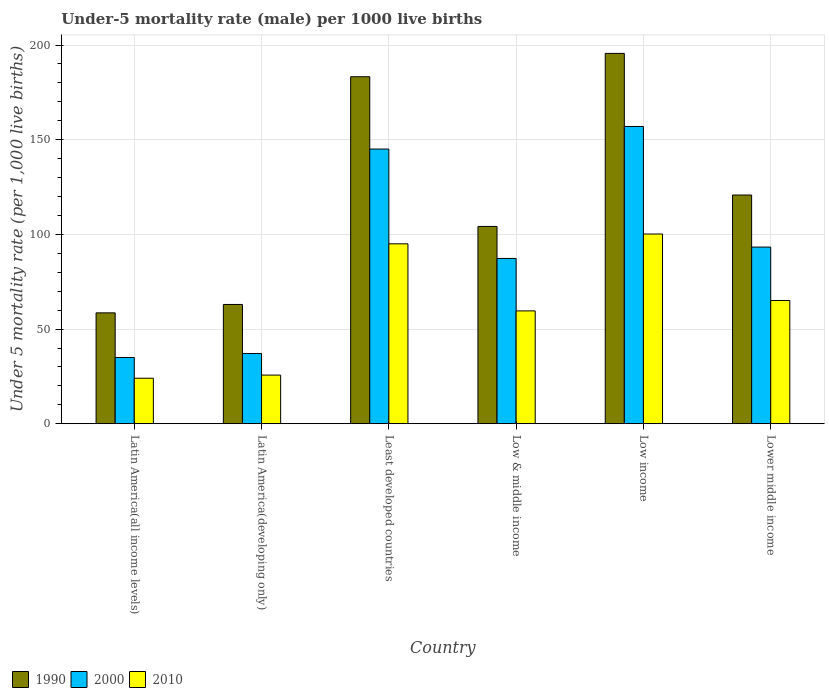How many different coloured bars are there?
Provide a succinct answer. 3. How many bars are there on the 4th tick from the right?
Offer a terse response. 3. What is the label of the 3rd group of bars from the left?
Give a very brief answer. Least developed countries. In how many cases, is the number of bars for a given country not equal to the number of legend labels?
Your answer should be compact. 0. What is the under-five mortality rate in 1990 in Low & middle income?
Make the answer very short. 104.2. Across all countries, what is the maximum under-five mortality rate in 2010?
Give a very brief answer. 100.2. Across all countries, what is the minimum under-five mortality rate in 1990?
Your answer should be very brief. 58.55. In which country was the under-five mortality rate in 1990 minimum?
Your answer should be very brief. Latin America(all income levels). What is the total under-five mortality rate in 2000 in the graph?
Offer a very short reply. 554.77. What is the difference between the under-five mortality rate in 1990 in Low & middle income and that in Low income?
Give a very brief answer. -91.4. What is the difference between the under-five mortality rate in 1990 in Low income and the under-five mortality rate in 2000 in Latin America(developing only)?
Provide a short and direct response. 158.5. What is the average under-five mortality rate in 1990 per country?
Your response must be concise. 120.91. What is the difference between the under-five mortality rate of/in 2010 and under-five mortality rate of/in 2000 in Low & middle income?
Make the answer very short. -27.7. In how many countries, is the under-five mortality rate in 2010 greater than 130?
Make the answer very short. 0. What is the ratio of the under-five mortality rate in 1990 in Low income to that in Lower middle income?
Make the answer very short. 1.62. Is the difference between the under-five mortality rate in 2010 in Low income and Lower middle income greater than the difference between the under-five mortality rate in 2000 in Low income and Lower middle income?
Provide a succinct answer. No. What is the difference between the highest and the second highest under-five mortality rate in 1990?
Your answer should be compact. -74.8. What is the difference between the highest and the lowest under-five mortality rate in 2010?
Keep it short and to the point. 76.16. In how many countries, is the under-five mortality rate in 1990 greater than the average under-five mortality rate in 1990 taken over all countries?
Make the answer very short. 2. Is the sum of the under-five mortality rate in 1990 in Latin America(all income levels) and Lower middle income greater than the maximum under-five mortality rate in 2010 across all countries?
Give a very brief answer. Yes. Are all the bars in the graph horizontal?
Your response must be concise. No. Where does the legend appear in the graph?
Provide a short and direct response. Bottom left. What is the title of the graph?
Provide a succinct answer. Under-5 mortality rate (male) per 1000 live births. What is the label or title of the X-axis?
Your response must be concise. Country. What is the label or title of the Y-axis?
Keep it short and to the point. Under 5 mortality rate (per 1,0 live births). What is the Under 5 mortality rate (per 1,000 live births) of 1990 in Latin America(all income levels)?
Provide a short and direct response. 58.55. What is the Under 5 mortality rate (per 1,000 live births) in 2000 in Latin America(all income levels)?
Your answer should be compact. 34.99. What is the Under 5 mortality rate (per 1,000 live births) of 2010 in Latin America(all income levels)?
Your answer should be very brief. 24.04. What is the Under 5 mortality rate (per 1,000 live births) in 1990 in Latin America(developing only)?
Your answer should be very brief. 63. What is the Under 5 mortality rate (per 1,000 live births) in 2000 in Latin America(developing only)?
Your answer should be compact. 37.1. What is the Under 5 mortality rate (per 1,000 live births) in 2010 in Latin America(developing only)?
Provide a short and direct response. 25.7. What is the Under 5 mortality rate (per 1,000 live births) in 1990 in Least developed countries?
Your response must be concise. 183.28. What is the Under 5 mortality rate (per 1,000 live births) of 2000 in Least developed countries?
Offer a very short reply. 145.08. What is the Under 5 mortality rate (per 1,000 live births) in 2010 in Least developed countries?
Your answer should be compact. 95.03. What is the Under 5 mortality rate (per 1,000 live births) in 1990 in Low & middle income?
Your answer should be very brief. 104.2. What is the Under 5 mortality rate (per 1,000 live births) in 2000 in Low & middle income?
Your answer should be compact. 87.3. What is the Under 5 mortality rate (per 1,000 live births) of 2010 in Low & middle income?
Offer a very short reply. 59.6. What is the Under 5 mortality rate (per 1,000 live births) in 1990 in Low income?
Make the answer very short. 195.6. What is the Under 5 mortality rate (per 1,000 live births) in 2000 in Low income?
Make the answer very short. 157. What is the Under 5 mortality rate (per 1,000 live births) in 2010 in Low income?
Your answer should be compact. 100.2. What is the Under 5 mortality rate (per 1,000 live births) of 1990 in Lower middle income?
Ensure brevity in your answer.  120.8. What is the Under 5 mortality rate (per 1,000 live births) in 2000 in Lower middle income?
Provide a succinct answer. 93.3. What is the Under 5 mortality rate (per 1,000 live births) of 2010 in Lower middle income?
Offer a very short reply. 65.1. Across all countries, what is the maximum Under 5 mortality rate (per 1,000 live births) of 1990?
Offer a terse response. 195.6. Across all countries, what is the maximum Under 5 mortality rate (per 1,000 live births) in 2000?
Provide a short and direct response. 157. Across all countries, what is the maximum Under 5 mortality rate (per 1,000 live births) in 2010?
Your response must be concise. 100.2. Across all countries, what is the minimum Under 5 mortality rate (per 1,000 live births) in 1990?
Your answer should be compact. 58.55. Across all countries, what is the minimum Under 5 mortality rate (per 1,000 live births) in 2000?
Your answer should be very brief. 34.99. Across all countries, what is the minimum Under 5 mortality rate (per 1,000 live births) in 2010?
Your answer should be very brief. 24.04. What is the total Under 5 mortality rate (per 1,000 live births) in 1990 in the graph?
Your answer should be very brief. 725.43. What is the total Under 5 mortality rate (per 1,000 live births) in 2000 in the graph?
Offer a very short reply. 554.77. What is the total Under 5 mortality rate (per 1,000 live births) in 2010 in the graph?
Offer a very short reply. 369.66. What is the difference between the Under 5 mortality rate (per 1,000 live births) of 1990 in Latin America(all income levels) and that in Latin America(developing only)?
Offer a very short reply. -4.45. What is the difference between the Under 5 mortality rate (per 1,000 live births) of 2000 in Latin America(all income levels) and that in Latin America(developing only)?
Your response must be concise. -2.11. What is the difference between the Under 5 mortality rate (per 1,000 live births) in 2010 in Latin America(all income levels) and that in Latin America(developing only)?
Offer a very short reply. -1.66. What is the difference between the Under 5 mortality rate (per 1,000 live births) of 1990 in Latin America(all income levels) and that in Least developed countries?
Ensure brevity in your answer.  -124.72. What is the difference between the Under 5 mortality rate (per 1,000 live births) in 2000 in Latin America(all income levels) and that in Least developed countries?
Keep it short and to the point. -110.09. What is the difference between the Under 5 mortality rate (per 1,000 live births) of 2010 in Latin America(all income levels) and that in Least developed countries?
Keep it short and to the point. -70.99. What is the difference between the Under 5 mortality rate (per 1,000 live births) in 1990 in Latin America(all income levels) and that in Low & middle income?
Provide a succinct answer. -45.65. What is the difference between the Under 5 mortality rate (per 1,000 live births) in 2000 in Latin America(all income levels) and that in Low & middle income?
Make the answer very short. -52.31. What is the difference between the Under 5 mortality rate (per 1,000 live births) of 2010 in Latin America(all income levels) and that in Low & middle income?
Ensure brevity in your answer.  -35.56. What is the difference between the Under 5 mortality rate (per 1,000 live births) in 1990 in Latin America(all income levels) and that in Low income?
Provide a short and direct response. -137.05. What is the difference between the Under 5 mortality rate (per 1,000 live births) of 2000 in Latin America(all income levels) and that in Low income?
Give a very brief answer. -122.01. What is the difference between the Under 5 mortality rate (per 1,000 live births) of 2010 in Latin America(all income levels) and that in Low income?
Ensure brevity in your answer.  -76.16. What is the difference between the Under 5 mortality rate (per 1,000 live births) in 1990 in Latin America(all income levels) and that in Lower middle income?
Give a very brief answer. -62.25. What is the difference between the Under 5 mortality rate (per 1,000 live births) of 2000 in Latin America(all income levels) and that in Lower middle income?
Your answer should be compact. -58.31. What is the difference between the Under 5 mortality rate (per 1,000 live births) in 2010 in Latin America(all income levels) and that in Lower middle income?
Make the answer very short. -41.06. What is the difference between the Under 5 mortality rate (per 1,000 live births) of 1990 in Latin America(developing only) and that in Least developed countries?
Give a very brief answer. -120.28. What is the difference between the Under 5 mortality rate (per 1,000 live births) in 2000 in Latin America(developing only) and that in Least developed countries?
Provide a succinct answer. -107.98. What is the difference between the Under 5 mortality rate (per 1,000 live births) of 2010 in Latin America(developing only) and that in Least developed countries?
Offer a very short reply. -69.33. What is the difference between the Under 5 mortality rate (per 1,000 live births) of 1990 in Latin America(developing only) and that in Low & middle income?
Your answer should be compact. -41.2. What is the difference between the Under 5 mortality rate (per 1,000 live births) in 2000 in Latin America(developing only) and that in Low & middle income?
Offer a terse response. -50.2. What is the difference between the Under 5 mortality rate (per 1,000 live births) in 2010 in Latin America(developing only) and that in Low & middle income?
Offer a terse response. -33.9. What is the difference between the Under 5 mortality rate (per 1,000 live births) of 1990 in Latin America(developing only) and that in Low income?
Provide a short and direct response. -132.6. What is the difference between the Under 5 mortality rate (per 1,000 live births) of 2000 in Latin America(developing only) and that in Low income?
Make the answer very short. -119.9. What is the difference between the Under 5 mortality rate (per 1,000 live births) in 2010 in Latin America(developing only) and that in Low income?
Provide a succinct answer. -74.5. What is the difference between the Under 5 mortality rate (per 1,000 live births) in 1990 in Latin America(developing only) and that in Lower middle income?
Give a very brief answer. -57.8. What is the difference between the Under 5 mortality rate (per 1,000 live births) of 2000 in Latin America(developing only) and that in Lower middle income?
Give a very brief answer. -56.2. What is the difference between the Under 5 mortality rate (per 1,000 live births) in 2010 in Latin America(developing only) and that in Lower middle income?
Your answer should be compact. -39.4. What is the difference between the Under 5 mortality rate (per 1,000 live births) in 1990 in Least developed countries and that in Low & middle income?
Provide a short and direct response. 79.08. What is the difference between the Under 5 mortality rate (per 1,000 live births) of 2000 in Least developed countries and that in Low & middle income?
Your answer should be very brief. 57.78. What is the difference between the Under 5 mortality rate (per 1,000 live births) of 2010 in Least developed countries and that in Low & middle income?
Keep it short and to the point. 35.43. What is the difference between the Under 5 mortality rate (per 1,000 live births) in 1990 in Least developed countries and that in Low income?
Provide a succinct answer. -12.32. What is the difference between the Under 5 mortality rate (per 1,000 live births) of 2000 in Least developed countries and that in Low income?
Ensure brevity in your answer.  -11.92. What is the difference between the Under 5 mortality rate (per 1,000 live births) in 2010 in Least developed countries and that in Low income?
Keep it short and to the point. -5.17. What is the difference between the Under 5 mortality rate (per 1,000 live births) in 1990 in Least developed countries and that in Lower middle income?
Keep it short and to the point. 62.48. What is the difference between the Under 5 mortality rate (per 1,000 live births) of 2000 in Least developed countries and that in Lower middle income?
Provide a short and direct response. 51.78. What is the difference between the Under 5 mortality rate (per 1,000 live births) of 2010 in Least developed countries and that in Lower middle income?
Your answer should be compact. 29.93. What is the difference between the Under 5 mortality rate (per 1,000 live births) in 1990 in Low & middle income and that in Low income?
Your answer should be compact. -91.4. What is the difference between the Under 5 mortality rate (per 1,000 live births) of 2000 in Low & middle income and that in Low income?
Give a very brief answer. -69.7. What is the difference between the Under 5 mortality rate (per 1,000 live births) in 2010 in Low & middle income and that in Low income?
Provide a succinct answer. -40.6. What is the difference between the Under 5 mortality rate (per 1,000 live births) in 1990 in Low & middle income and that in Lower middle income?
Ensure brevity in your answer.  -16.6. What is the difference between the Under 5 mortality rate (per 1,000 live births) of 2000 in Low & middle income and that in Lower middle income?
Your answer should be compact. -6. What is the difference between the Under 5 mortality rate (per 1,000 live births) of 1990 in Low income and that in Lower middle income?
Your answer should be very brief. 74.8. What is the difference between the Under 5 mortality rate (per 1,000 live births) of 2000 in Low income and that in Lower middle income?
Provide a short and direct response. 63.7. What is the difference between the Under 5 mortality rate (per 1,000 live births) of 2010 in Low income and that in Lower middle income?
Keep it short and to the point. 35.1. What is the difference between the Under 5 mortality rate (per 1,000 live births) of 1990 in Latin America(all income levels) and the Under 5 mortality rate (per 1,000 live births) of 2000 in Latin America(developing only)?
Your answer should be very brief. 21.45. What is the difference between the Under 5 mortality rate (per 1,000 live births) in 1990 in Latin America(all income levels) and the Under 5 mortality rate (per 1,000 live births) in 2010 in Latin America(developing only)?
Your answer should be very brief. 32.85. What is the difference between the Under 5 mortality rate (per 1,000 live births) of 2000 in Latin America(all income levels) and the Under 5 mortality rate (per 1,000 live births) of 2010 in Latin America(developing only)?
Give a very brief answer. 9.29. What is the difference between the Under 5 mortality rate (per 1,000 live births) of 1990 in Latin America(all income levels) and the Under 5 mortality rate (per 1,000 live births) of 2000 in Least developed countries?
Offer a very short reply. -86.52. What is the difference between the Under 5 mortality rate (per 1,000 live births) of 1990 in Latin America(all income levels) and the Under 5 mortality rate (per 1,000 live births) of 2010 in Least developed countries?
Offer a very short reply. -36.47. What is the difference between the Under 5 mortality rate (per 1,000 live births) in 2000 in Latin America(all income levels) and the Under 5 mortality rate (per 1,000 live births) in 2010 in Least developed countries?
Your response must be concise. -60.04. What is the difference between the Under 5 mortality rate (per 1,000 live births) in 1990 in Latin America(all income levels) and the Under 5 mortality rate (per 1,000 live births) in 2000 in Low & middle income?
Ensure brevity in your answer.  -28.75. What is the difference between the Under 5 mortality rate (per 1,000 live births) in 1990 in Latin America(all income levels) and the Under 5 mortality rate (per 1,000 live births) in 2010 in Low & middle income?
Your response must be concise. -1.05. What is the difference between the Under 5 mortality rate (per 1,000 live births) in 2000 in Latin America(all income levels) and the Under 5 mortality rate (per 1,000 live births) in 2010 in Low & middle income?
Your answer should be compact. -24.61. What is the difference between the Under 5 mortality rate (per 1,000 live births) of 1990 in Latin America(all income levels) and the Under 5 mortality rate (per 1,000 live births) of 2000 in Low income?
Make the answer very short. -98.45. What is the difference between the Under 5 mortality rate (per 1,000 live births) of 1990 in Latin America(all income levels) and the Under 5 mortality rate (per 1,000 live births) of 2010 in Low income?
Keep it short and to the point. -41.65. What is the difference between the Under 5 mortality rate (per 1,000 live births) of 2000 in Latin America(all income levels) and the Under 5 mortality rate (per 1,000 live births) of 2010 in Low income?
Make the answer very short. -65.21. What is the difference between the Under 5 mortality rate (per 1,000 live births) of 1990 in Latin America(all income levels) and the Under 5 mortality rate (per 1,000 live births) of 2000 in Lower middle income?
Ensure brevity in your answer.  -34.75. What is the difference between the Under 5 mortality rate (per 1,000 live births) in 1990 in Latin America(all income levels) and the Under 5 mortality rate (per 1,000 live births) in 2010 in Lower middle income?
Your answer should be very brief. -6.55. What is the difference between the Under 5 mortality rate (per 1,000 live births) in 2000 in Latin America(all income levels) and the Under 5 mortality rate (per 1,000 live births) in 2010 in Lower middle income?
Ensure brevity in your answer.  -30.11. What is the difference between the Under 5 mortality rate (per 1,000 live births) of 1990 in Latin America(developing only) and the Under 5 mortality rate (per 1,000 live births) of 2000 in Least developed countries?
Provide a short and direct response. -82.08. What is the difference between the Under 5 mortality rate (per 1,000 live births) of 1990 in Latin America(developing only) and the Under 5 mortality rate (per 1,000 live births) of 2010 in Least developed countries?
Provide a succinct answer. -32.03. What is the difference between the Under 5 mortality rate (per 1,000 live births) of 2000 in Latin America(developing only) and the Under 5 mortality rate (per 1,000 live births) of 2010 in Least developed countries?
Your answer should be very brief. -57.93. What is the difference between the Under 5 mortality rate (per 1,000 live births) in 1990 in Latin America(developing only) and the Under 5 mortality rate (per 1,000 live births) in 2000 in Low & middle income?
Offer a very short reply. -24.3. What is the difference between the Under 5 mortality rate (per 1,000 live births) in 2000 in Latin America(developing only) and the Under 5 mortality rate (per 1,000 live births) in 2010 in Low & middle income?
Give a very brief answer. -22.5. What is the difference between the Under 5 mortality rate (per 1,000 live births) of 1990 in Latin America(developing only) and the Under 5 mortality rate (per 1,000 live births) of 2000 in Low income?
Provide a succinct answer. -94. What is the difference between the Under 5 mortality rate (per 1,000 live births) in 1990 in Latin America(developing only) and the Under 5 mortality rate (per 1,000 live births) in 2010 in Low income?
Offer a terse response. -37.2. What is the difference between the Under 5 mortality rate (per 1,000 live births) of 2000 in Latin America(developing only) and the Under 5 mortality rate (per 1,000 live births) of 2010 in Low income?
Provide a short and direct response. -63.1. What is the difference between the Under 5 mortality rate (per 1,000 live births) in 1990 in Latin America(developing only) and the Under 5 mortality rate (per 1,000 live births) in 2000 in Lower middle income?
Provide a succinct answer. -30.3. What is the difference between the Under 5 mortality rate (per 1,000 live births) in 1990 in Latin America(developing only) and the Under 5 mortality rate (per 1,000 live births) in 2010 in Lower middle income?
Offer a terse response. -2.1. What is the difference between the Under 5 mortality rate (per 1,000 live births) of 1990 in Least developed countries and the Under 5 mortality rate (per 1,000 live births) of 2000 in Low & middle income?
Give a very brief answer. 95.98. What is the difference between the Under 5 mortality rate (per 1,000 live births) in 1990 in Least developed countries and the Under 5 mortality rate (per 1,000 live births) in 2010 in Low & middle income?
Provide a short and direct response. 123.68. What is the difference between the Under 5 mortality rate (per 1,000 live births) of 2000 in Least developed countries and the Under 5 mortality rate (per 1,000 live births) of 2010 in Low & middle income?
Offer a terse response. 85.48. What is the difference between the Under 5 mortality rate (per 1,000 live births) in 1990 in Least developed countries and the Under 5 mortality rate (per 1,000 live births) in 2000 in Low income?
Keep it short and to the point. 26.28. What is the difference between the Under 5 mortality rate (per 1,000 live births) of 1990 in Least developed countries and the Under 5 mortality rate (per 1,000 live births) of 2010 in Low income?
Make the answer very short. 83.08. What is the difference between the Under 5 mortality rate (per 1,000 live births) of 2000 in Least developed countries and the Under 5 mortality rate (per 1,000 live births) of 2010 in Low income?
Your response must be concise. 44.88. What is the difference between the Under 5 mortality rate (per 1,000 live births) of 1990 in Least developed countries and the Under 5 mortality rate (per 1,000 live births) of 2000 in Lower middle income?
Provide a succinct answer. 89.98. What is the difference between the Under 5 mortality rate (per 1,000 live births) of 1990 in Least developed countries and the Under 5 mortality rate (per 1,000 live births) of 2010 in Lower middle income?
Offer a very short reply. 118.18. What is the difference between the Under 5 mortality rate (per 1,000 live births) in 2000 in Least developed countries and the Under 5 mortality rate (per 1,000 live births) in 2010 in Lower middle income?
Ensure brevity in your answer.  79.98. What is the difference between the Under 5 mortality rate (per 1,000 live births) of 1990 in Low & middle income and the Under 5 mortality rate (per 1,000 live births) of 2000 in Low income?
Give a very brief answer. -52.8. What is the difference between the Under 5 mortality rate (per 1,000 live births) in 1990 in Low & middle income and the Under 5 mortality rate (per 1,000 live births) in 2010 in Lower middle income?
Offer a terse response. 39.1. What is the difference between the Under 5 mortality rate (per 1,000 live births) of 1990 in Low income and the Under 5 mortality rate (per 1,000 live births) of 2000 in Lower middle income?
Provide a succinct answer. 102.3. What is the difference between the Under 5 mortality rate (per 1,000 live births) in 1990 in Low income and the Under 5 mortality rate (per 1,000 live births) in 2010 in Lower middle income?
Offer a very short reply. 130.5. What is the difference between the Under 5 mortality rate (per 1,000 live births) in 2000 in Low income and the Under 5 mortality rate (per 1,000 live births) in 2010 in Lower middle income?
Provide a short and direct response. 91.9. What is the average Under 5 mortality rate (per 1,000 live births) in 1990 per country?
Give a very brief answer. 120.91. What is the average Under 5 mortality rate (per 1,000 live births) of 2000 per country?
Your response must be concise. 92.46. What is the average Under 5 mortality rate (per 1,000 live births) in 2010 per country?
Provide a short and direct response. 61.61. What is the difference between the Under 5 mortality rate (per 1,000 live births) of 1990 and Under 5 mortality rate (per 1,000 live births) of 2000 in Latin America(all income levels)?
Make the answer very short. 23.57. What is the difference between the Under 5 mortality rate (per 1,000 live births) of 1990 and Under 5 mortality rate (per 1,000 live births) of 2010 in Latin America(all income levels)?
Your response must be concise. 34.52. What is the difference between the Under 5 mortality rate (per 1,000 live births) in 2000 and Under 5 mortality rate (per 1,000 live births) in 2010 in Latin America(all income levels)?
Your response must be concise. 10.95. What is the difference between the Under 5 mortality rate (per 1,000 live births) of 1990 and Under 5 mortality rate (per 1,000 live births) of 2000 in Latin America(developing only)?
Offer a very short reply. 25.9. What is the difference between the Under 5 mortality rate (per 1,000 live births) in 1990 and Under 5 mortality rate (per 1,000 live births) in 2010 in Latin America(developing only)?
Your answer should be compact. 37.3. What is the difference between the Under 5 mortality rate (per 1,000 live births) in 1990 and Under 5 mortality rate (per 1,000 live births) in 2000 in Least developed countries?
Give a very brief answer. 38.2. What is the difference between the Under 5 mortality rate (per 1,000 live births) in 1990 and Under 5 mortality rate (per 1,000 live births) in 2010 in Least developed countries?
Provide a short and direct response. 88.25. What is the difference between the Under 5 mortality rate (per 1,000 live births) of 2000 and Under 5 mortality rate (per 1,000 live births) of 2010 in Least developed countries?
Your answer should be very brief. 50.05. What is the difference between the Under 5 mortality rate (per 1,000 live births) of 1990 and Under 5 mortality rate (per 1,000 live births) of 2000 in Low & middle income?
Provide a short and direct response. 16.9. What is the difference between the Under 5 mortality rate (per 1,000 live births) in 1990 and Under 5 mortality rate (per 1,000 live births) in 2010 in Low & middle income?
Provide a succinct answer. 44.6. What is the difference between the Under 5 mortality rate (per 1,000 live births) in 2000 and Under 5 mortality rate (per 1,000 live births) in 2010 in Low & middle income?
Ensure brevity in your answer.  27.7. What is the difference between the Under 5 mortality rate (per 1,000 live births) of 1990 and Under 5 mortality rate (per 1,000 live births) of 2000 in Low income?
Make the answer very short. 38.6. What is the difference between the Under 5 mortality rate (per 1,000 live births) in 1990 and Under 5 mortality rate (per 1,000 live births) in 2010 in Low income?
Make the answer very short. 95.4. What is the difference between the Under 5 mortality rate (per 1,000 live births) in 2000 and Under 5 mortality rate (per 1,000 live births) in 2010 in Low income?
Your response must be concise. 56.8. What is the difference between the Under 5 mortality rate (per 1,000 live births) in 1990 and Under 5 mortality rate (per 1,000 live births) in 2000 in Lower middle income?
Your response must be concise. 27.5. What is the difference between the Under 5 mortality rate (per 1,000 live births) of 1990 and Under 5 mortality rate (per 1,000 live births) of 2010 in Lower middle income?
Your answer should be very brief. 55.7. What is the difference between the Under 5 mortality rate (per 1,000 live births) of 2000 and Under 5 mortality rate (per 1,000 live births) of 2010 in Lower middle income?
Ensure brevity in your answer.  28.2. What is the ratio of the Under 5 mortality rate (per 1,000 live births) in 1990 in Latin America(all income levels) to that in Latin America(developing only)?
Provide a short and direct response. 0.93. What is the ratio of the Under 5 mortality rate (per 1,000 live births) of 2000 in Latin America(all income levels) to that in Latin America(developing only)?
Offer a terse response. 0.94. What is the ratio of the Under 5 mortality rate (per 1,000 live births) of 2010 in Latin America(all income levels) to that in Latin America(developing only)?
Offer a very short reply. 0.94. What is the ratio of the Under 5 mortality rate (per 1,000 live births) of 1990 in Latin America(all income levels) to that in Least developed countries?
Ensure brevity in your answer.  0.32. What is the ratio of the Under 5 mortality rate (per 1,000 live births) in 2000 in Latin America(all income levels) to that in Least developed countries?
Ensure brevity in your answer.  0.24. What is the ratio of the Under 5 mortality rate (per 1,000 live births) of 2010 in Latin America(all income levels) to that in Least developed countries?
Offer a terse response. 0.25. What is the ratio of the Under 5 mortality rate (per 1,000 live births) of 1990 in Latin America(all income levels) to that in Low & middle income?
Make the answer very short. 0.56. What is the ratio of the Under 5 mortality rate (per 1,000 live births) of 2000 in Latin America(all income levels) to that in Low & middle income?
Your answer should be compact. 0.4. What is the ratio of the Under 5 mortality rate (per 1,000 live births) in 2010 in Latin America(all income levels) to that in Low & middle income?
Provide a succinct answer. 0.4. What is the ratio of the Under 5 mortality rate (per 1,000 live births) in 1990 in Latin America(all income levels) to that in Low income?
Ensure brevity in your answer.  0.3. What is the ratio of the Under 5 mortality rate (per 1,000 live births) of 2000 in Latin America(all income levels) to that in Low income?
Ensure brevity in your answer.  0.22. What is the ratio of the Under 5 mortality rate (per 1,000 live births) in 2010 in Latin America(all income levels) to that in Low income?
Offer a very short reply. 0.24. What is the ratio of the Under 5 mortality rate (per 1,000 live births) in 1990 in Latin America(all income levels) to that in Lower middle income?
Your answer should be very brief. 0.48. What is the ratio of the Under 5 mortality rate (per 1,000 live births) of 2000 in Latin America(all income levels) to that in Lower middle income?
Your response must be concise. 0.38. What is the ratio of the Under 5 mortality rate (per 1,000 live births) in 2010 in Latin America(all income levels) to that in Lower middle income?
Provide a succinct answer. 0.37. What is the ratio of the Under 5 mortality rate (per 1,000 live births) of 1990 in Latin America(developing only) to that in Least developed countries?
Your answer should be very brief. 0.34. What is the ratio of the Under 5 mortality rate (per 1,000 live births) in 2000 in Latin America(developing only) to that in Least developed countries?
Offer a terse response. 0.26. What is the ratio of the Under 5 mortality rate (per 1,000 live births) in 2010 in Latin America(developing only) to that in Least developed countries?
Your answer should be compact. 0.27. What is the ratio of the Under 5 mortality rate (per 1,000 live births) in 1990 in Latin America(developing only) to that in Low & middle income?
Provide a short and direct response. 0.6. What is the ratio of the Under 5 mortality rate (per 1,000 live births) of 2000 in Latin America(developing only) to that in Low & middle income?
Ensure brevity in your answer.  0.42. What is the ratio of the Under 5 mortality rate (per 1,000 live births) in 2010 in Latin America(developing only) to that in Low & middle income?
Ensure brevity in your answer.  0.43. What is the ratio of the Under 5 mortality rate (per 1,000 live births) of 1990 in Latin America(developing only) to that in Low income?
Provide a short and direct response. 0.32. What is the ratio of the Under 5 mortality rate (per 1,000 live births) of 2000 in Latin America(developing only) to that in Low income?
Offer a terse response. 0.24. What is the ratio of the Under 5 mortality rate (per 1,000 live births) in 2010 in Latin America(developing only) to that in Low income?
Offer a terse response. 0.26. What is the ratio of the Under 5 mortality rate (per 1,000 live births) of 1990 in Latin America(developing only) to that in Lower middle income?
Make the answer very short. 0.52. What is the ratio of the Under 5 mortality rate (per 1,000 live births) of 2000 in Latin America(developing only) to that in Lower middle income?
Give a very brief answer. 0.4. What is the ratio of the Under 5 mortality rate (per 1,000 live births) in 2010 in Latin America(developing only) to that in Lower middle income?
Offer a terse response. 0.39. What is the ratio of the Under 5 mortality rate (per 1,000 live births) of 1990 in Least developed countries to that in Low & middle income?
Provide a succinct answer. 1.76. What is the ratio of the Under 5 mortality rate (per 1,000 live births) of 2000 in Least developed countries to that in Low & middle income?
Make the answer very short. 1.66. What is the ratio of the Under 5 mortality rate (per 1,000 live births) in 2010 in Least developed countries to that in Low & middle income?
Offer a terse response. 1.59. What is the ratio of the Under 5 mortality rate (per 1,000 live births) of 1990 in Least developed countries to that in Low income?
Offer a terse response. 0.94. What is the ratio of the Under 5 mortality rate (per 1,000 live births) of 2000 in Least developed countries to that in Low income?
Provide a short and direct response. 0.92. What is the ratio of the Under 5 mortality rate (per 1,000 live births) of 2010 in Least developed countries to that in Low income?
Give a very brief answer. 0.95. What is the ratio of the Under 5 mortality rate (per 1,000 live births) in 1990 in Least developed countries to that in Lower middle income?
Provide a succinct answer. 1.52. What is the ratio of the Under 5 mortality rate (per 1,000 live births) in 2000 in Least developed countries to that in Lower middle income?
Offer a very short reply. 1.55. What is the ratio of the Under 5 mortality rate (per 1,000 live births) of 2010 in Least developed countries to that in Lower middle income?
Keep it short and to the point. 1.46. What is the ratio of the Under 5 mortality rate (per 1,000 live births) in 1990 in Low & middle income to that in Low income?
Your answer should be compact. 0.53. What is the ratio of the Under 5 mortality rate (per 1,000 live births) in 2000 in Low & middle income to that in Low income?
Offer a terse response. 0.56. What is the ratio of the Under 5 mortality rate (per 1,000 live births) of 2010 in Low & middle income to that in Low income?
Offer a terse response. 0.59. What is the ratio of the Under 5 mortality rate (per 1,000 live births) of 1990 in Low & middle income to that in Lower middle income?
Your response must be concise. 0.86. What is the ratio of the Under 5 mortality rate (per 1,000 live births) of 2000 in Low & middle income to that in Lower middle income?
Your answer should be very brief. 0.94. What is the ratio of the Under 5 mortality rate (per 1,000 live births) of 2010 in Low & middle income to that in Lower middle income?
Your answer should be compact. 0.92. What is the ratio of the Under 5 mortality rate (per 1,000 live births) in 1990 in Low income to that in Lower middle income?
Your answer should be very brief. 1.62. What is the ratio of the Under 5 mortality rate (per 1,000 live births) of 2000 in Low income to that in Lower middle income?
Give a very brief answer. 1.68. What is the ratio of the Under 5 mortality rate (per 1,000 live births) in 2010 in Low income to that in Lower middle income?
Your answer should be compact. 1.54. What is the difference between the highest and the second highest Under 5 mortality rate (per 1,000 live births) of 1990?
Offer a very short reply. 12.32. What is the difference between the highest and the second highest Under 5 mortality rate (per 1,000 live births) in 2000?
Your answer should be compact. 11.92. What is the difference between the highest and the second highest Under 5 mortality rate (per 1,000 live births) in 2010?
Ensure brevity in your answer.  5.17. What is the difference between the highest and the lowest Under 5 mortality rate (per 1,000 live births) in 1990?
Provide a succinct answer. 137.05. What is the difference between the highest and the lowest Under 5 mortality rate (per 1,000 live births) of 2000?
Your answer should be compact. 122.01. What is the difference between the highest and the lowest Under 5 mortality rate (per 1,000 live births) of 2010?
Keep it short and to the point. 76.16. 